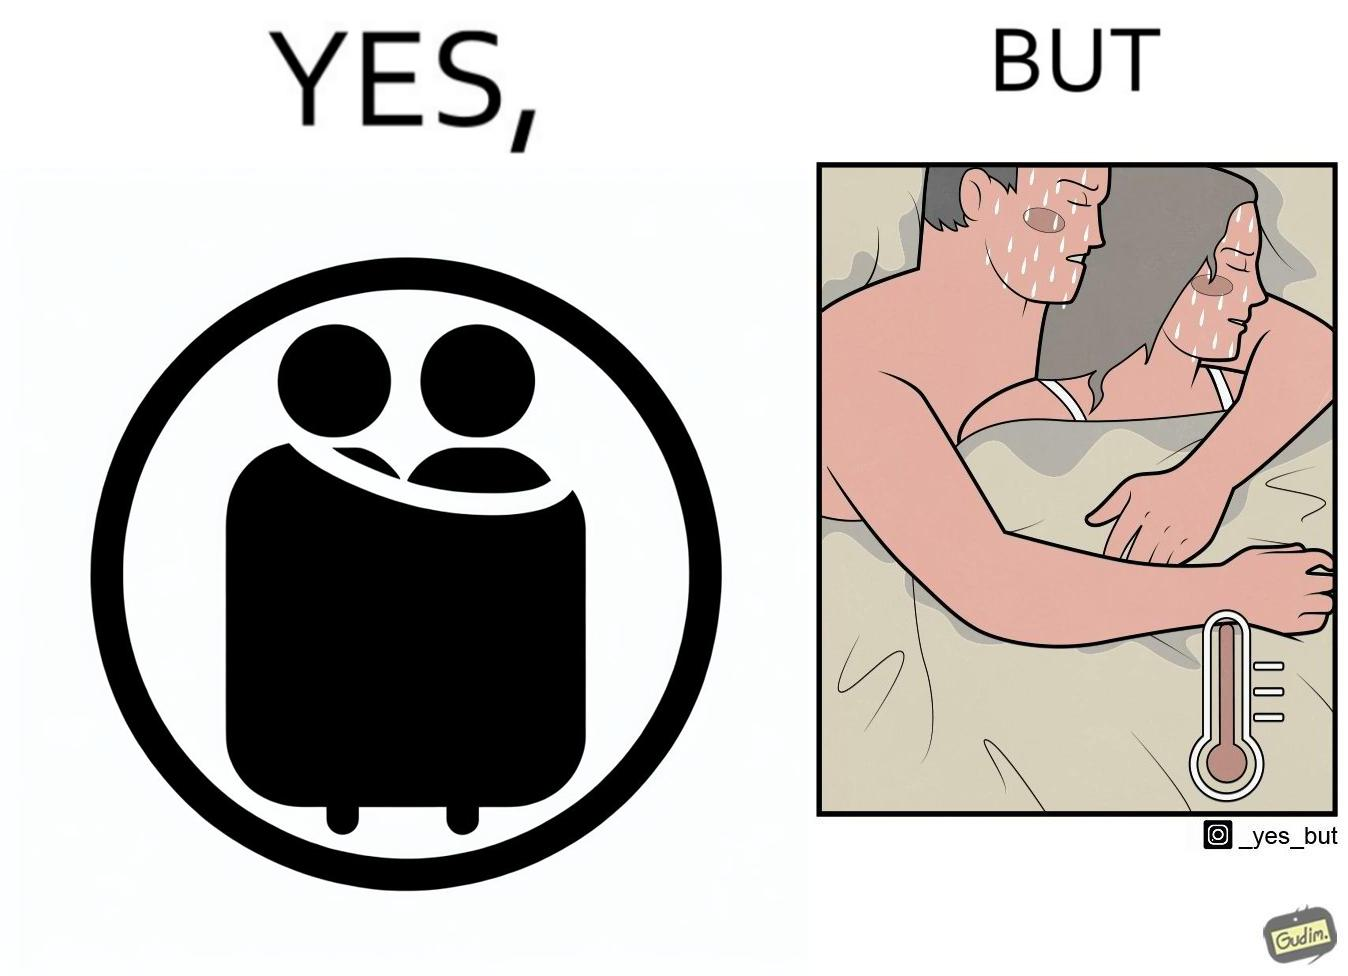Describe the contrast between the left and right parts of this image. In the left part of the image: a couple cuddling together in a blanket In the right part of the image: a couple feeling sweaty while cuddling together in a blanket 